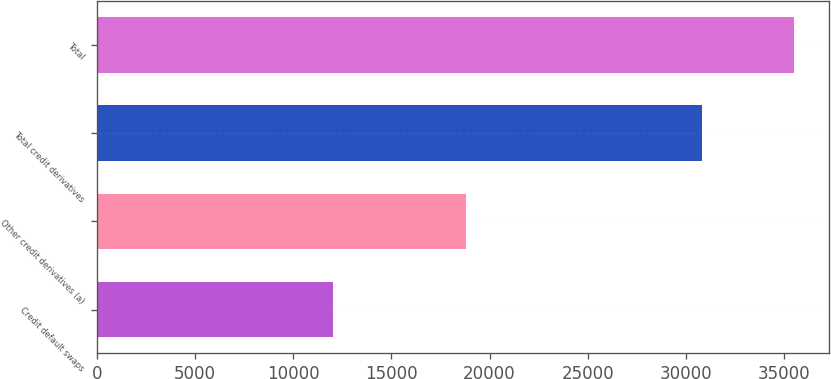Convert chart to OTSL. <chart><loc_0><loc_0><loc_500><loc_500><bar_chart><fcel>Credit default swaps<fcel>Other credit derivatives (a)<fcel>Total credit derivatives<fcel>Total<nl><fcel>12011<fcel>18792<fcel>30803<fcel>35518<nl></chart> 